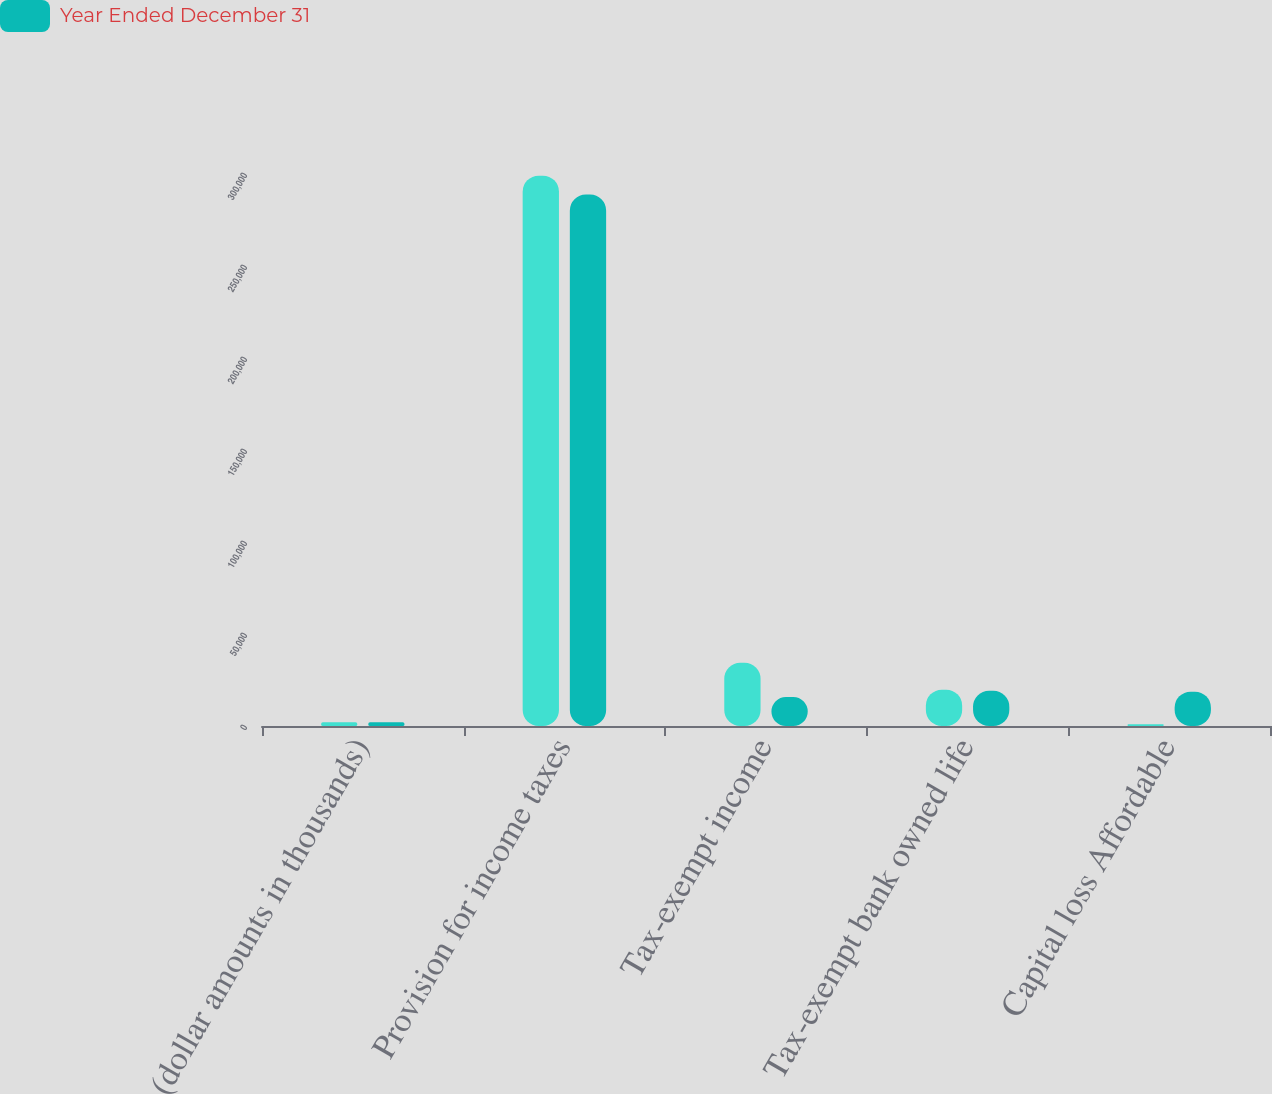<chart> <loc_0><loc_0><loc_500><loc_500><stacked_bar_chart><ecel><fcel>(dollar amounts in thousands)<fcel>Provision for income taxes<fcel>Tax-exempt income<fcel>Tax-exempt bank owned life<fcel>Capital loss Affordable<nl><fcel>nan<fcel>2013<fcel>299094<fcel>34378<fcel>19747<fcel>961<nl><fcel>Year Ended December 31<fcel>2012<fcel>288791<fcel>15752<fcel>19151<fcel>18659<nl></chart> 